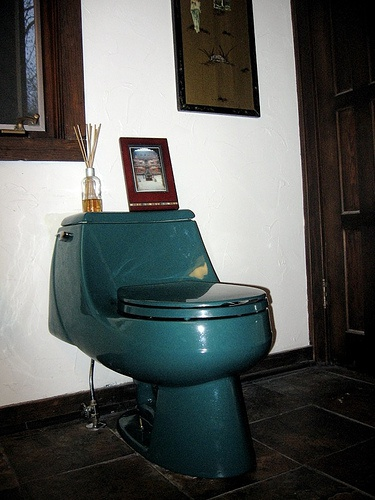Describe the objects in this image and their specific colors. I can see toilet in black, teal, and gray tones and vase in black, white, darkgray, olive, and tan tones in this image. 